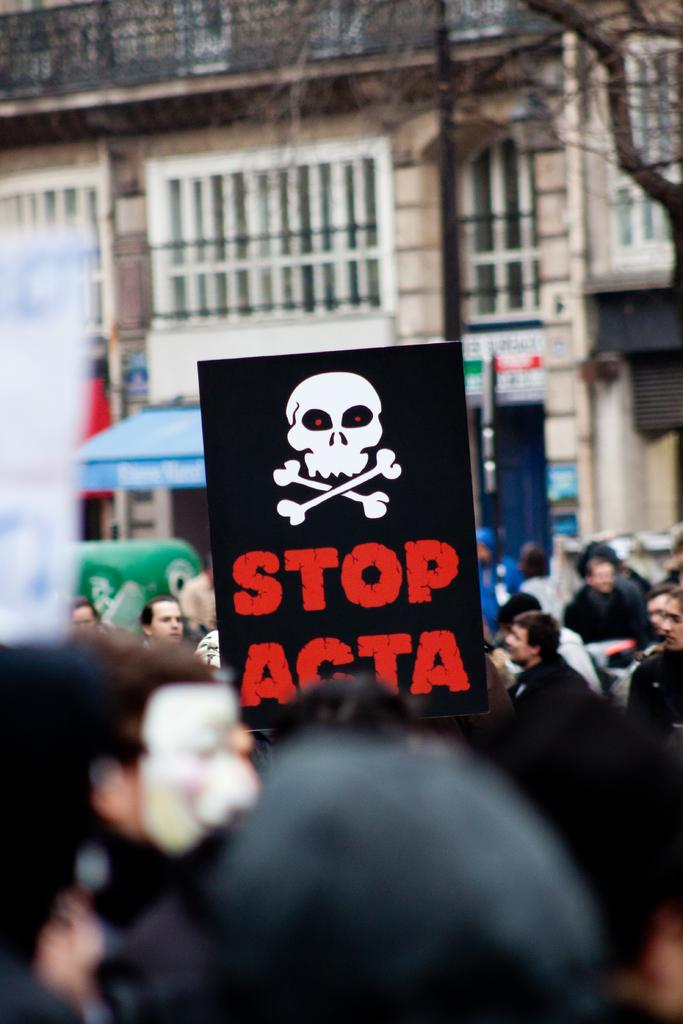How many people are in the image? There is a group of people in the image. What can be seen on the wall in the image? There is a poster in the image. What is depicted on the poster? The poster contains a danger symbol. What else is on the poster besides the danger symbol? The poster has some text. What is visible in the background of the image? There is a building in the background of the image. Can you tell me how many owls are sitting on the faucet in the image? There are no owls or faucets present in the image. What type of match is being used to light the poster in the image? There is no match or lighting of the poster in the image; it is a static poster with a danger symbol and text. 